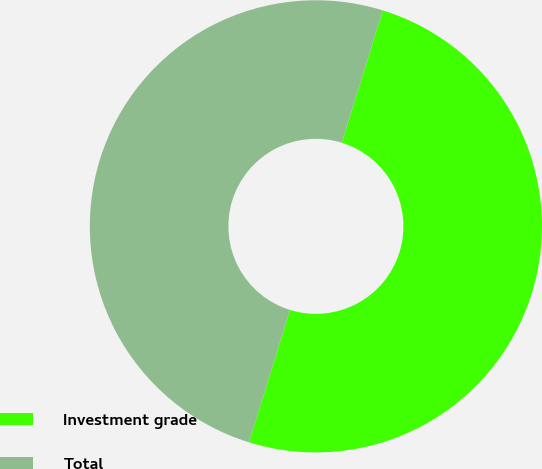<chart> <loc_0><loc_0><loc_500><loc_500><pie_chart><fcel>Investment grade<fcel>Total<nl><fcel>50.0%<fcel>50.0%<nl></chart> 